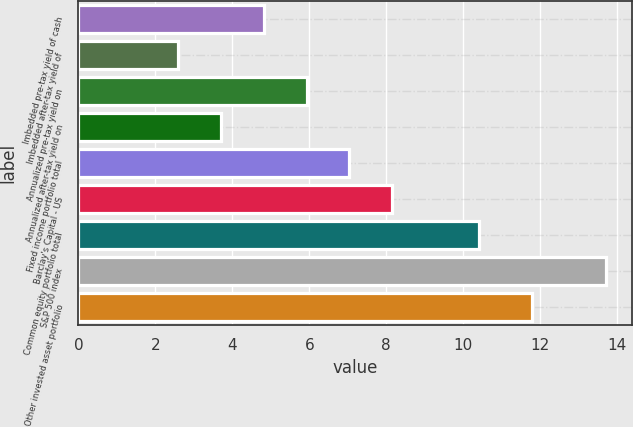<chart> <loc_0><loc_0><loc_500><loc_500><bar_chart><fcel>Imbedded pre-tax yield of cash<fcel>Imbedded after-tax yield of<fcel>Annualized pre-tax yield on<fcel>Annualized after-tax yield on<fcel>Fixed income portfolio total<fcel>Barclay's Capital - US<fcel>Common equity portfolio total<fcel>S&P 500 index<fcel>Other invested asset portfolio<nl><fcel>4.82<fcel>2.6<fcel>5.93<fcel>3.71<fcel>7.04<fcel>8.15<fcel>10.4<fcel>13.7<fcel>11.8<nl></chart> 